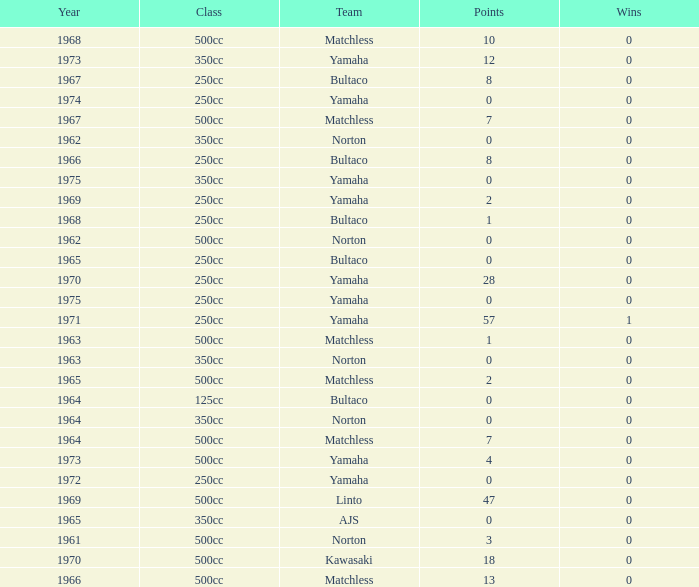What is the sum of all points in 1975 with 0 wins? None. 